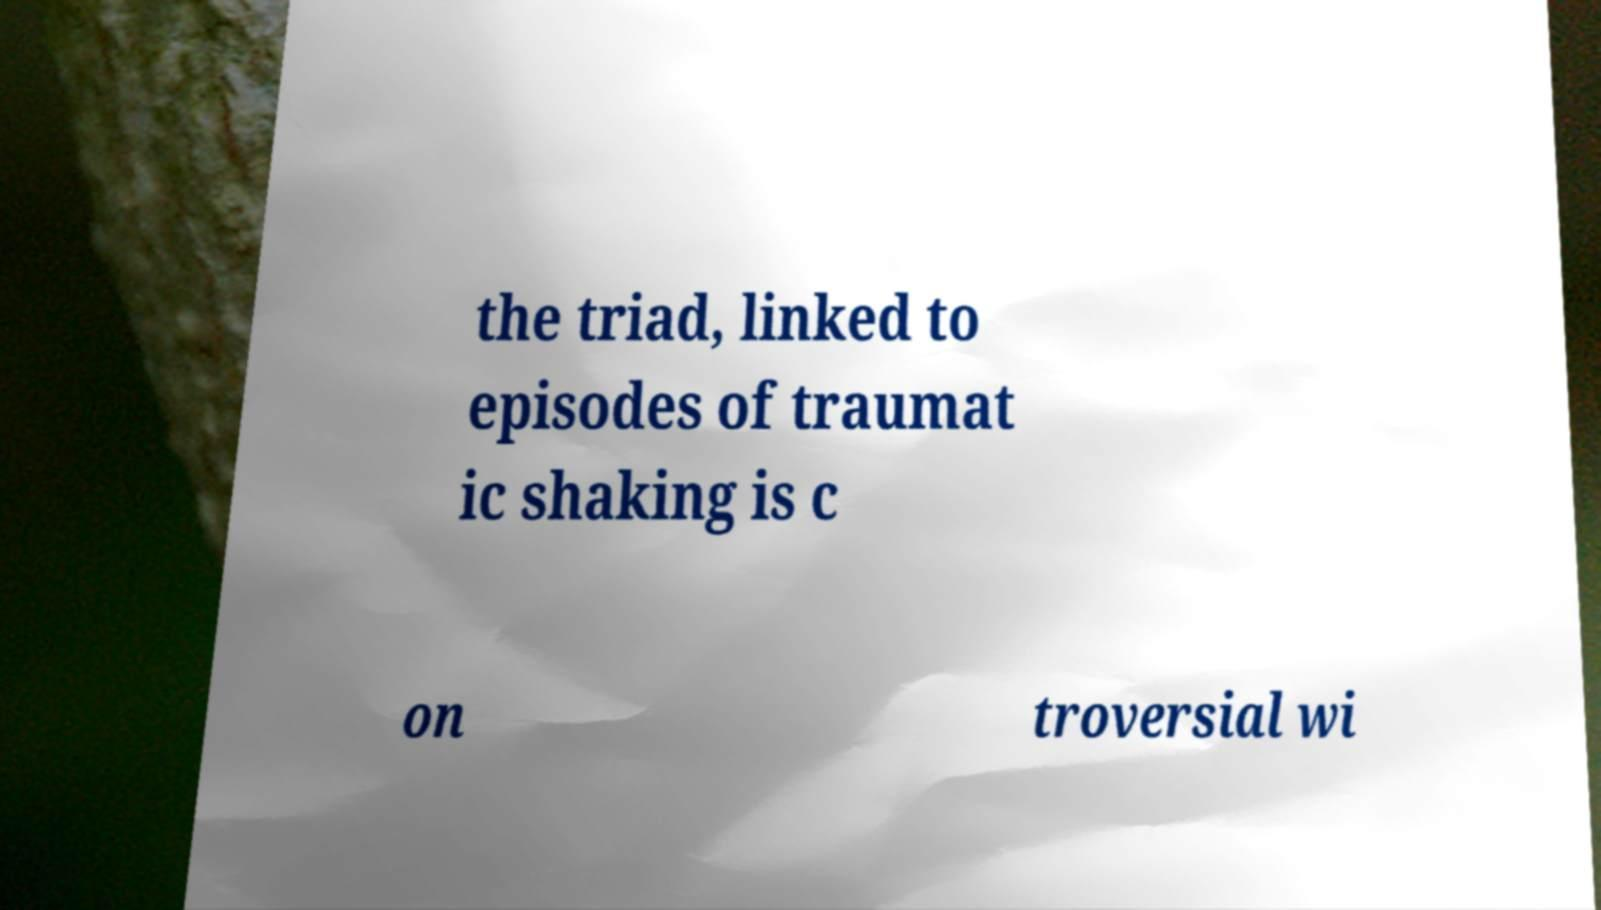I need the written content from this picture converted into text. Can you do that? the triad, linked to episodes of traumat ic shaking is c on troversial wi 